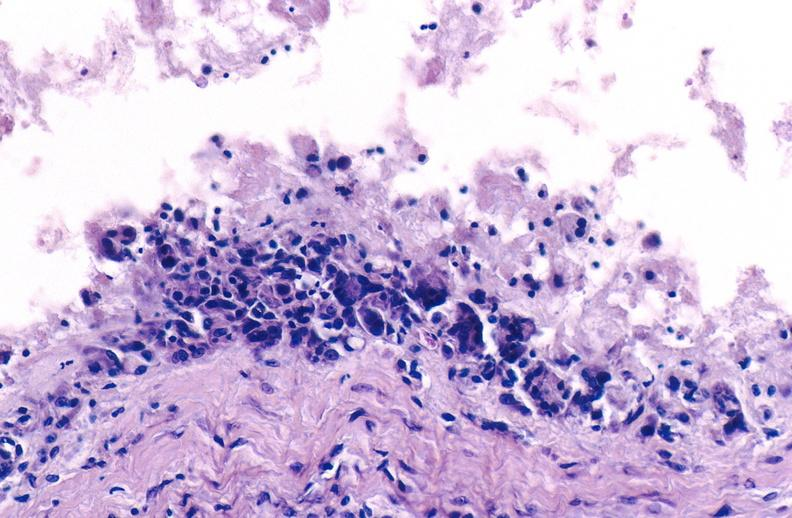s cushings disease present?
Answer the question using a single word or phrase. No 